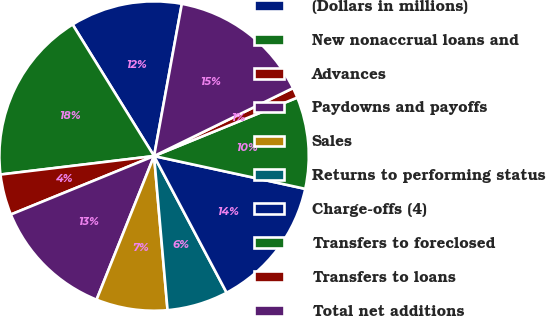<chart> <loc_0><loc_0><loc_500><loc_500><pie_chart><fcel>(Dollars in millions)<fcel>New nonaccrual loans and<fcel>Advances<fcel>Paydowns and payoffs<fcel>Sales<fcel>Returns to performing status<fcel>Charge-offs (4)<fcel>Transfers to foreclosed<fcel>Transfers to loans<fcel>Total net additions<nl><fcel>11.7%<fcel>18.08%<fcel>4.26%<fcel>12.77%<fcel>7.45%<fcel>6.38%<fcel>13.83%<fcel>9.57%<fcel>1.07%<fcel>14.89%<nl></chart> 